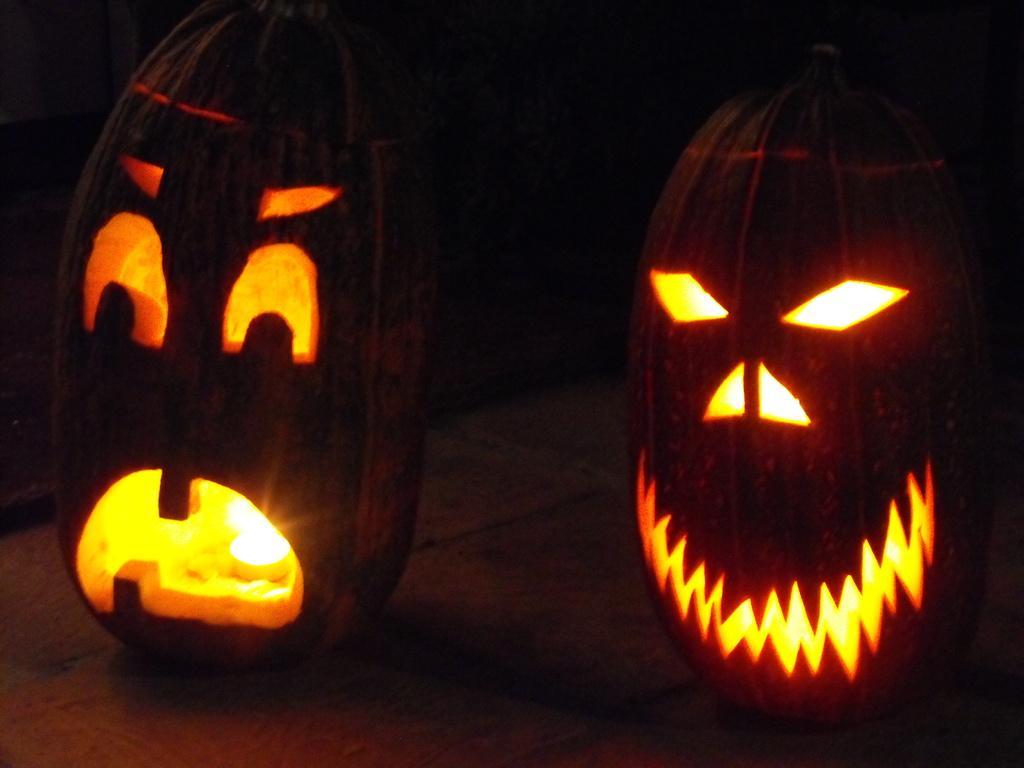Could you give a brief overview of what you see in this image? In this picture we can see two pumpkins, there is a dark background, we can see a light here. 